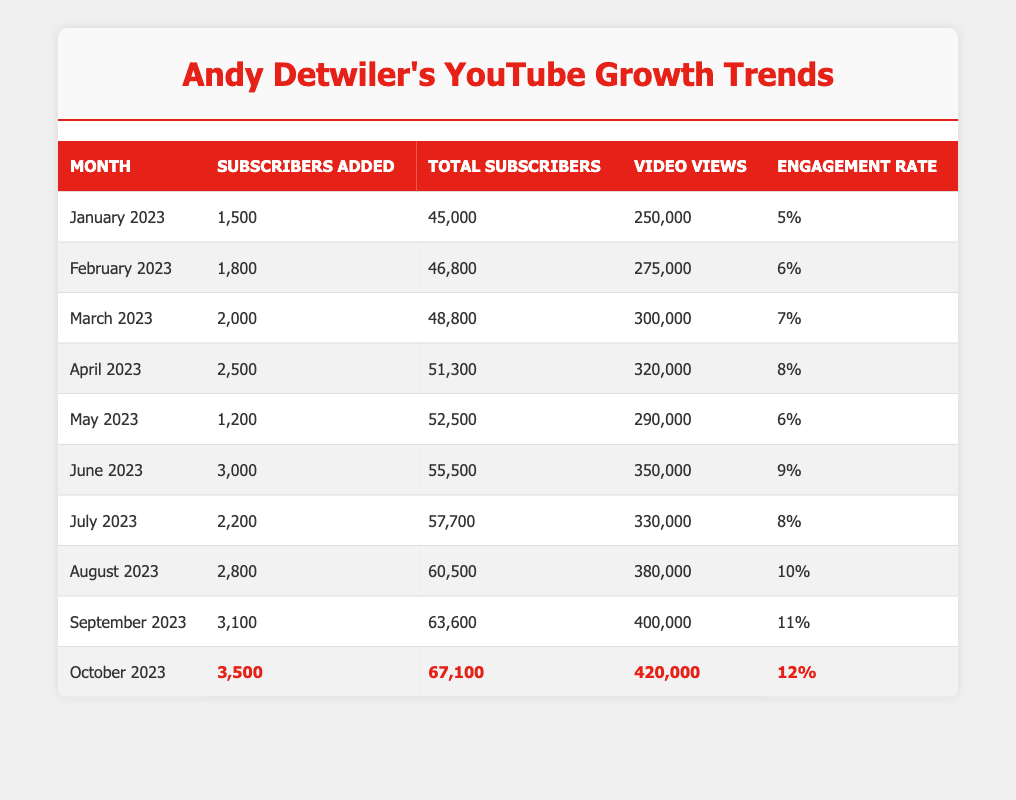What was the total number of subscribers at the end of June 2023? In June 2023, the total number of subscribers was reported as 55,500 in the table.
Answer: 55,500 How many subscribers were added in August 2023? The table indicates that in August 2023, 2,800 subscribers were added.
Answer: 2,800 What is the engagement rate for October 2023? The engagement rate for October 2023, as stated in the table, is 12%.
Answer: 12% Which month had the highest number of subscribers added? By reviewing the "Subscribers Added" column, October 2023 shows the highest increase with 3,500 subscribers.
Answer: October 2023 What was the average engagement rate from January to September 2023? The engagement rates from January to September are 5%, 6%, 7%, 8%, 6%, 9%, 10%, and 11%. Adding them gives a total of 52%, and dividing by 8 (the number of months) results in an average of 6.5%.
Answer: 6.5% Did Andy Detwiler experience a decrease in the total number of subscribers at any point between January and October 2023? A review of the "Total Subscribers" column shows that the total subscriber count increased every month, indicating there were no decreases in subscriber numbers during this period.
Answer: No What was the percentage increase in subscribers from May to June 2023? The total subscribers went from 52,500 in May to 55,500 in June. The increase is 3,000 subscribers. The percentage increase is calculated as (3,000 / 52,500) * 100, which is approximately 5.71%.
Answer: Approximately 5.71% How many more subscribers were added in September than in July 2023? The subscribers added in September 2023 was 3,100, while in July 2023, it was 2,200. The difference is 3,100 - 2,200 = 900 more subscribers in September.
Answer: 900 What was the total number of video views in August 2023? According to the table, August 2023 had a total of 380,000 video views.
Answer: 380,000 